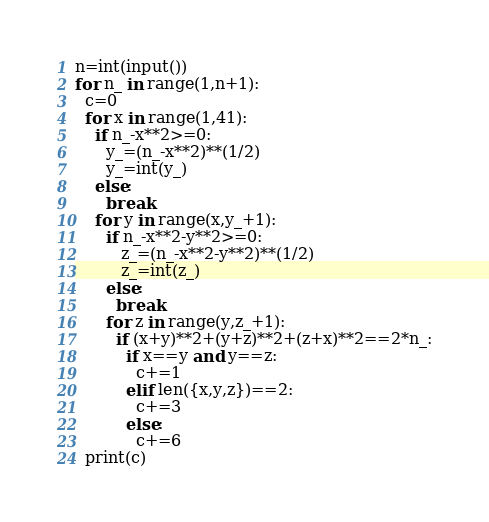<code> <loc_0><loc_0><loc_500><loc_500><_Python_>n=int(input())
for n_ in range(1,n+1):
  c=0
  for x in range(1,41):
    if n_-x**2>=0:
      y_=(n_-x**2)**(1/2)
      y_=int(y_)
    else:
      break
    for y in range(x,y_+1):
      if n_-x**2-y**2>=0:
         z_=(n_-x**2-y**2)**(1/2)
         z_=int(z_)
      else:
        break
      for z in range(y,z_+1):
        if (x+y)**2+(y+z)**2+(z+x)**2==2*n_:
          if x==y and y==z:
            c+=1	
          elif len({x,y,z})==2:
            c+=3
          else:
            c+=6
  print(c)          </code> 